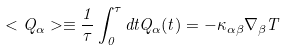<formula> <loc_0><loc_0><loc_500><loc_500>< Q _ { \alpha } > \equiv \frac { 1 } { \tau } \int _ { 0 } ^ { \tau } d t Q _ { \alpha } ( t ) = - \kappa _ { \alpha \beta } \nabla _ { \beta } T</formula> 